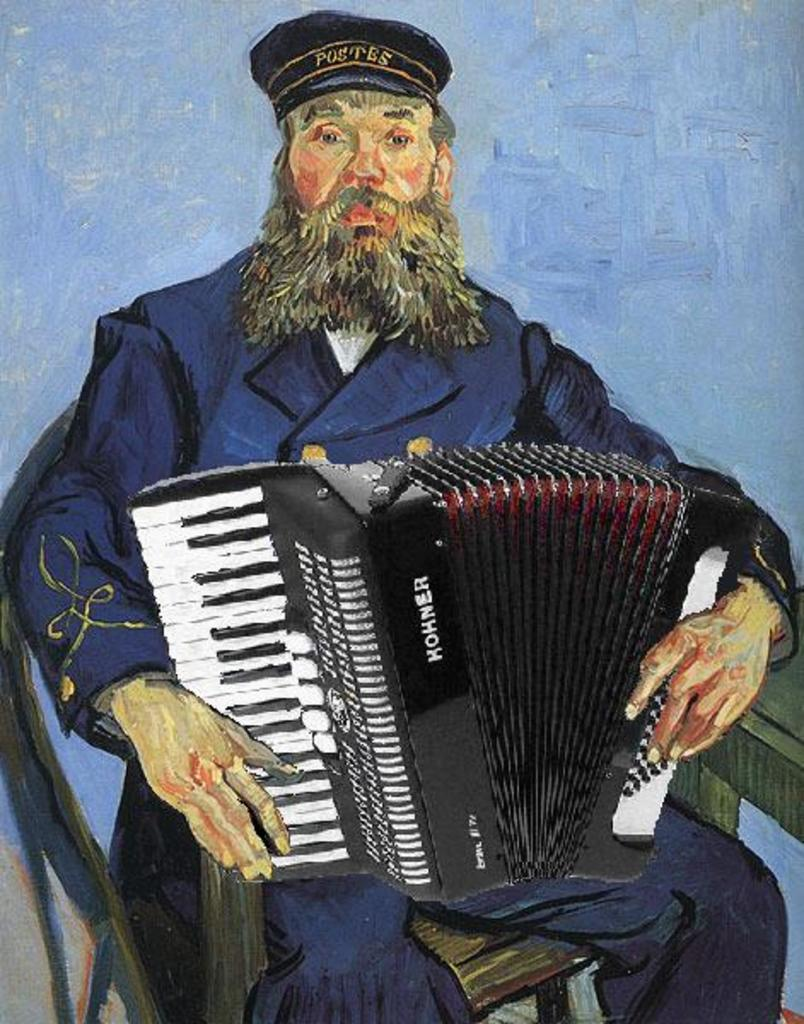What is the main subject of the painting in the image? The painting depicts a man. What is the man wearing in the painting? The man is wearing a cap. What is the man's posture in the painting? The man is sitting on a chair. What object is the man holding in the painting? The man is holding an accordion. What color are the man's toenails in the painting? There is no information about the man's toenails in the image, so we cannot determine their color. 